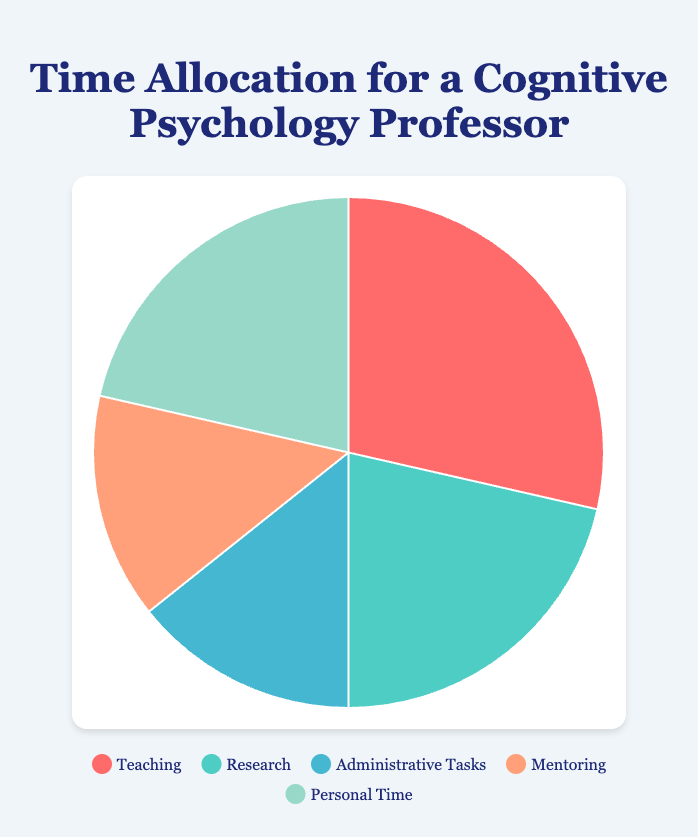What percentage of the total time is spent on Teaching? The total time spent on all activities is (4+3+2+2+3) = 14 hours. Teaching takes 4 hours. To find the percentage: (4/14) * 100 ≈ 28.57%.
Answer: 28.57% How much more time is spent on Teaching compared to Administrative Tasks? Teaching takes 4 hours, and Administrative Tasks take 2 hours. The difference is 4 - 2 = 2 hours.
Answer: 2 hours Is more time spent on Research or Personal Time? Both Research and Personal Time take 3 hours each. They are equal.
Answer: Equal What is the total time spent on activities other than Teaching? Total time spent on activities other than Teaching = 14 - 4 = 10 hours.
Answer: 10 hours What fraction of the total time is devoted to Mentoring? Total time is 14 hours. Mentoring takes 2 hours. The fraction is 2/14, which simplifies to 1/7.
Answer: 1/7 How many hours are allocated to tasks other than Research? Total hours other than Research = Total hours (14) - Research hours (3) = 11 hours.
Answer: 11 hours Which activity takes up the smallest portion of the day? Both Administrative Tasks and Mentoring take 2 hours each, which are the smallest.
Answer: Administrative Tasks and Mentoring If Teaching were increased by 1 hour, what would the new percentage of time spent on Teaching be? New total hours = 14 + 1 = 15. New Teaching hours = 4 + 1 = 5. New percentage = (5/15) * 100 ≈ 33.33%.
Answer: 33.33% What is the difference in hours between the most and least time-consuming activities? The most time-consuming activity is Teaching (4 hours), and the least are Administrative Tasks and Mentoring (2 hours each). The difference is 4 - 2 = 2 hours.
Answer: 2 hours 